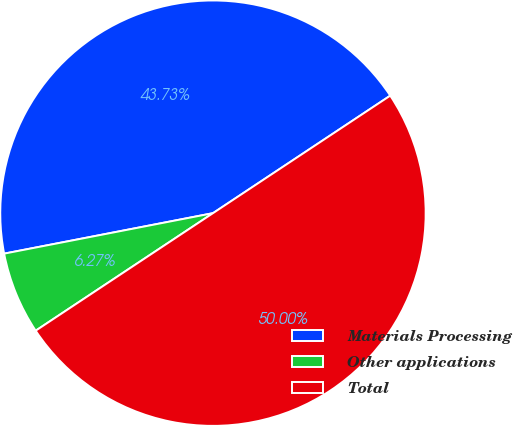<chart> <loc_0><loc_0><loc_500><loc_500><pie_chart><fcel>Materials Processing<fcel>Other applications<fcel>Total<nl><fcel>43.73%<fcel>6.27%<fcel>50.0%<nl></chart> 